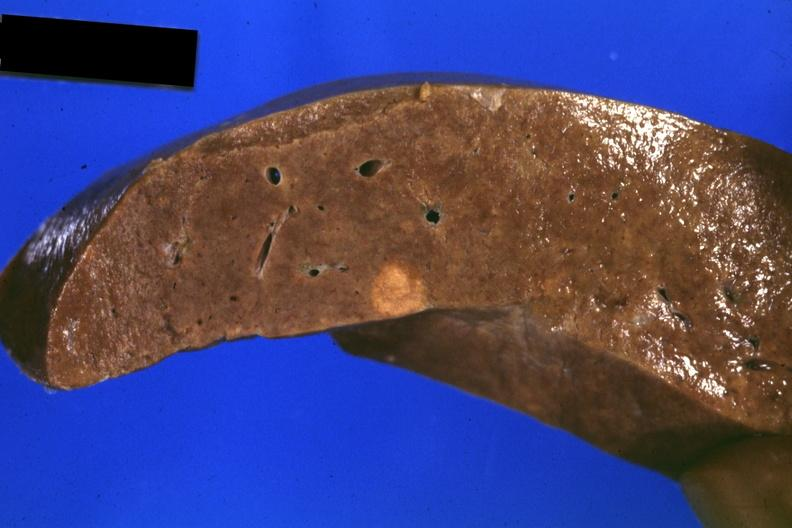s this person present?
Answer the question using a single word or phrase. No 